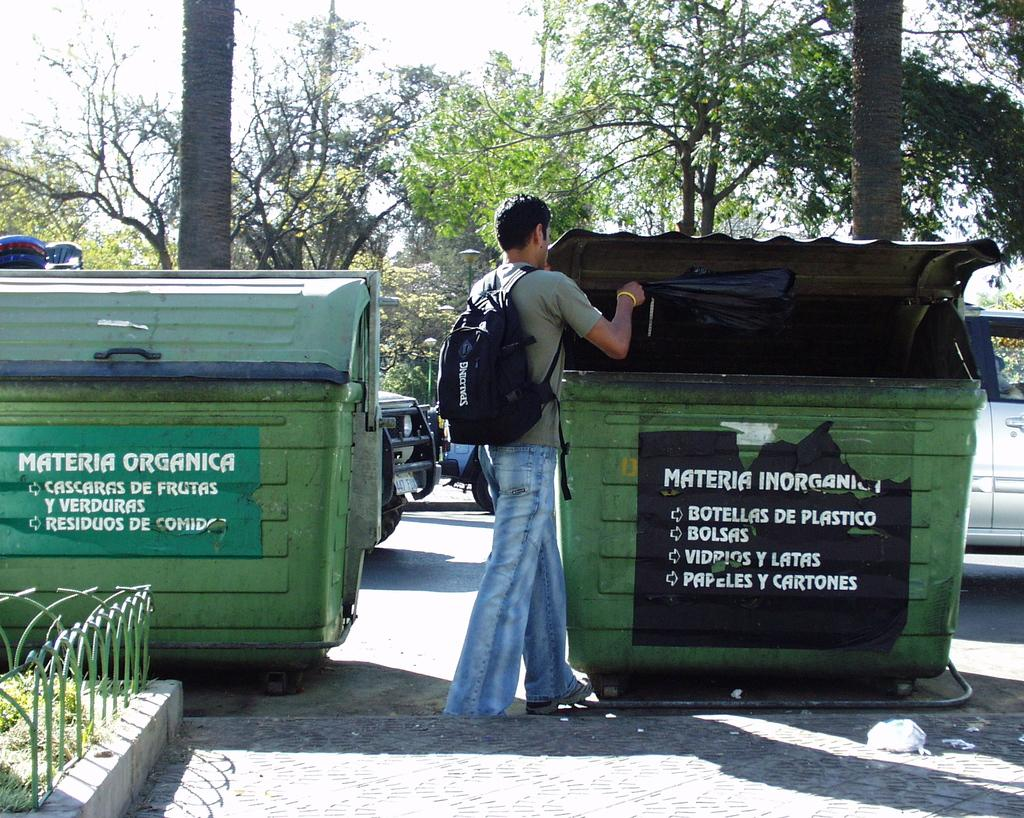<image>
Share a concise interpretation of the image provided. A young male drops waste into a dumpster labelled as accepting bolsas. 